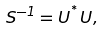<formula> <loc_0><loc_0><loc_500><loc_500>S ^ { - 1 } = U ^ { ^ { * } } U ,</formula> 